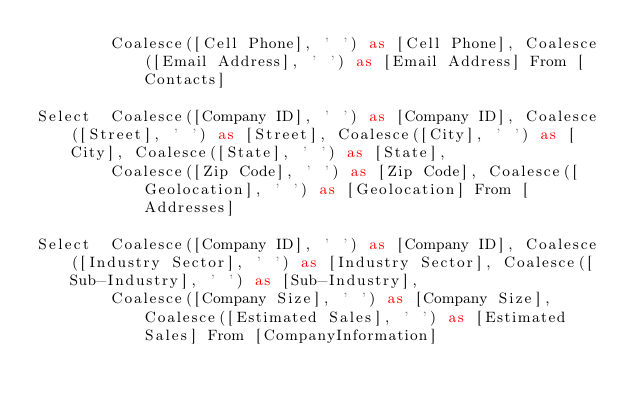<code> <loc_0><loc_0><loc_500><loc_500><_SQL_>		Coalesce([Cell Phone], ' ') as [Cell Phone], Coalesce([Email Address], ' ') as [Email Address] From [Contacts]

Select  Coalesce([Company ID], ' ') as [Company ID], Coalesce([Street], ' ') as [Street], Coalesce([City], ' ') as [City], Coalesce([State], ' ') as [State], 
		Coalesce([Zip Code], ' ') as [Zip Code], Coalesce([Geolocation], ' ') as [Geolocation] From [Addresses]

Select  Coalesce([Company ID], ' ') as [Company ID], Coalesce([Industry Sector], ' ') as [Industry Sector], Coalesce([Sub-Industry], ' ') as [Sub-Industry], 
		Coalesce([Company Size], ' ') as [Company Size], Coalesce([Estimated Sales], ' ') as [Estimated Sales] From [CompanyInformation]
</code> 